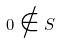<formula> <loc_0><loc_0><loc_500><loc_500>0 \notin S</formula> 